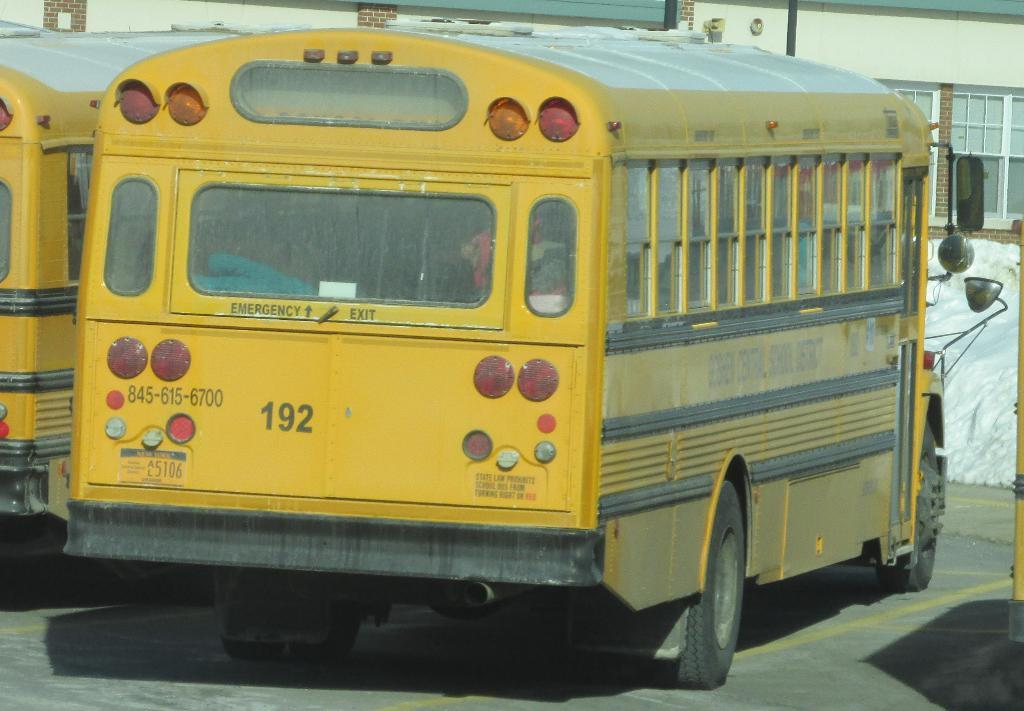Provide a one-sentence caption for the provided image. A yellow school bus sitting in a lot with other busses. 